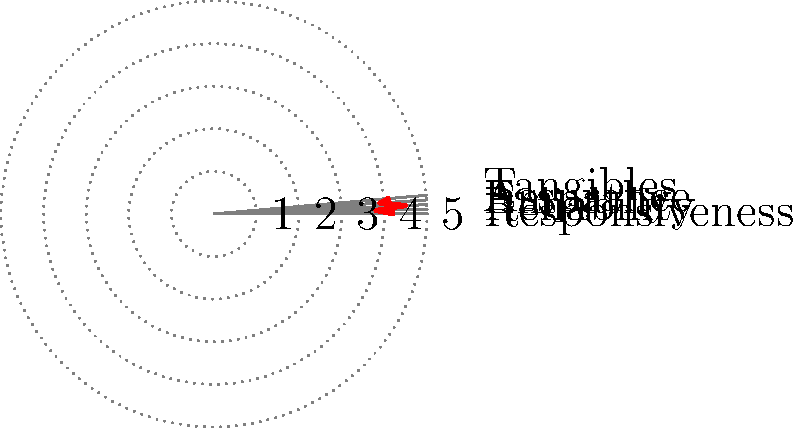Based on the radar chart showing customer satisfaction ratings across five dimensions, which area appears to have the highest satisfaction score? To determine the dimension with the highest satisfaction score, we need to analyze the radar chart:

1. The radar chart displays five dimensions of customer satisfaction: Responsiveness, Reliability, Empathy, Assurance, and Tangibles.

2. Each dimension is represented by a spoke on the chart, with scores ranging from 0 (center) to 5 (outer edge).

3. The red line connecting the data points forms a polygon, where the distance from the center represents the score for each dimension.

4. By visually comparing the position of each data point on its respective spoke, we can identify which dimension extends furthest from the center.

5. Examining the chart, we can see that the spoke representing "Empathy" extends the furthest from the center.

6. The data point for Empathy appears to be closest to the 4.5 mark on its spoke.

Therefore, Empathy has the highest satisfaction score among the five dimensions shown in the radar chart.
Answer: Empathy 